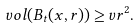Convert formula to latex. <formula><loc_0><loc_0><loc_500><loc_500>\ v o l ( B _ { t } ( x , r ) ) \geq v r ^ { 2 } .</formula> 